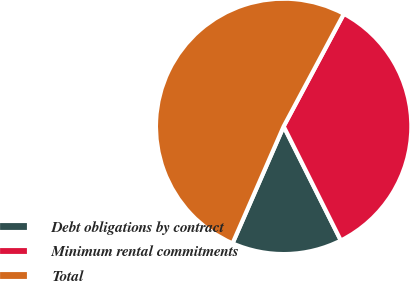<chart> <loc_0><loc_0><loc_500><loc_500><pie_chart><fcel>Debt obligations by contract<fcel>Minimum rental commitments<fcel>Total<nl><fcel>13.95%<fcel>34.79%<fcel>51.26%<nl></chart> 